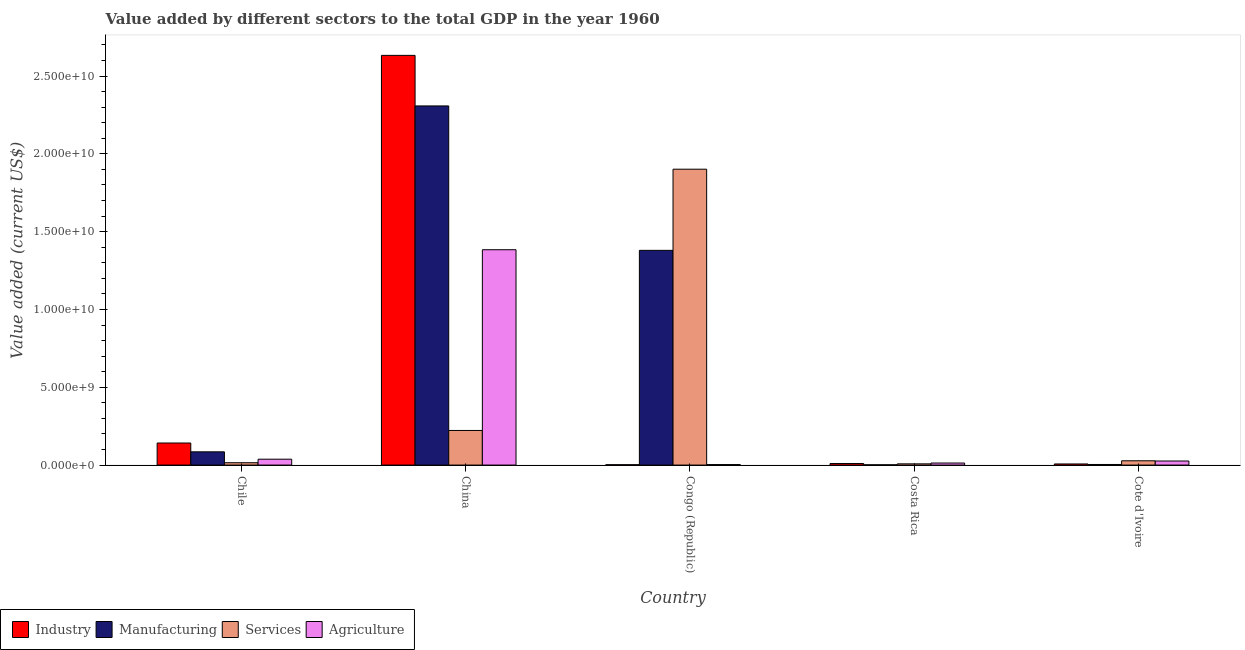Are the number of bars per tick equal to the number of legend labels?
Offer a very short reply. Yes. How many bars are there on the 3rd tick from the left?
Your answer should be compact. 4. What is the label of the 1st group of bars from the left?
Offer a very short reply. Chile. In how many cases, is the number of bars for a given country not equal to the number of legend labels?
Make the answer very short. 0. What is the value added by industrial sector in Chile?
Keep it short and to the point. 1.42e+09. Across all countries, what is the maximum value added by manufacturing sector?
Give a very brief answer. 2.31e+1. Across all countries, what is the minimum value added by agricultural sector?
Keep it short and to the point. 3.11e+07. In which country was the value added by services sector maximum?
Give a very brief answer. Congo (Republic). What is the total value added by manufacturing sector in the graph?
Your answer should be compact. 3.78e+1. What is the difference between the value added by services sector in China and that in Cote d'Ivoire?
Your response must be concise. 1.95e+09. What is the difference between the value added by industrial sector in Congo (Republic) and the value added by services sector in Chile?
Keep it short and to the point. -1.29e+08. What is the average value added by industrial sector per country?
Make the answer very short. 5.59e+09. What is the difference between the value added by industrial sector and value added by agricultural sector in China?
Offer a very short reply. 1.25e+1. In how many countries, is the value added by agricultural sector greater than 20000000000 US$?
Provide a short and direct response. 0. What is the ratio of the value added by agricultural sector in Congo (Republic) to that in Cote d'Ivoire?
Provide a succinct answer. 0.12. Is the value added by agricultural sector in Chile less than that in Costa Rica?
Offer a very short reply. No. Is the difference between the value added by manufacturing sector in Congo (Republic) and Cote d'Ivoire greater than the difference between the value added by industrial sector in Congo (Republic) and Cote d'Ivoire?
Offer a terse response. Yes. What is the difference between the highest and the second highest value added by manufacturing sector?
Make the answer very short. 9.28e+09. What is the difference between the highest and the lowest value added by manufacturing sector?
Your answer should be compact. 2.31e+1. In how many countries, is the value added by agricultural sector greater than the average value added by agricultural sector taken over all countries?
Offer a terse response. 1. Is the sum of the value added by industrial sector in Congo (Republic) and Costa Rica greater than the maximum value added by manufacturing sector across all countries?
Provide a short and direct response. No. Is it the case that in every country, the sum of the value added by manufacturing sector and value added by agricultural sector is greater than the sum of value added by industrial sector and value added by services sector?
Provide a short and direct response. Yes. What does the 3rd bar from the left in Costa Rica represents?
Offer a very short reply. Services. What does the 3rd bar from the right in Congo (Republic) represents?
Provide a short and direct response. Manufacturing. How many bars are there?
Offer a very short reply. 20. Are all the bars in the graph horizontal?
Your answer should be compact. No. Are the values on the major ticks of Y-axis written in scientific E-notation?
Your answer should be compact. Yes. Does the graph contain any zero values?
Provide a succinct answer. No. Does the graph contain grids?
Your response must be concise. No. How many legend labels are there?
Ensure brevity in your answer.  4. How are the legend labels stacked?
Provide a succinct answer. Horizontal. What is the title of the graph?
Your answer should be very brief. Value added by different sectors to the total GDP in the year 1960. What is the label or title of the Y-axis?
Make the answer very short. Value added (current US$). What is the Value added (current US$) in Industry in Chile?
Your response must be concise. 1.42e+09. What is the Value added (current US$) in Manufacturing in Chile?
Ensure brevity in your answer.  8.51e+08. What is the Value added (current US$) of Services in Chile?
Your response must be concise. 1.51e+08. What is the Value added (current US$) in Agriculture in Chile?
Give a very brief answer. 3.78e+08. What is the Value added (current US$) of Industry in China?
Offer a very short reply. 2.63e+1. What is the Value added (current US$) in Manufacturing in China?
Provide a succinct answer. 2.31e+1. What is the Value added (current US$) of Services in China?
Provide a succinct answer. 2.22e+09. What is the Value added (current US$) in Agriculture in China?
Offer a terse response. 1.38e+1. What is the Value added (current US$) of Industry in Congo (Republic)?
Give a very brief answer. 2.24e+07. What is the Value added (current US$) of Manufacturing in Congo (Republic)?
Provide a short and direct response. 1.38e+1. What is the Value added (current US$) of Services in Congo (Republic)?
Make the answer very short. 1.90e+1. What is the Value added (current US$) of Agriculture in Congo (Republic)?
Offer a very short reply. 3.11e+07. What is the Value added (current US$) in Industry in Costa Rica?
Give a very brief answer. 9.99e+07. What is the Value added (current US$) in Manufacturing in Costa Rica?
Ensure brevity in your answer.  1.59e+07. What is the Value added (current US$) of Services in Costa Rica?
Your answer should be very brief. 7.82e+07. What is the Value added (current US$) of Agriculture in Costa Rica?
Provide a short and direct response. 1.32e+08. What is the Value added (current US$) of Industry in Cote d'Ivoire?
Give a very brief answer. 7.18e+07. What is the Value added (current US$) in Manufacturing in Cote d'Ivoire?
Keep it short and to the point. 3.80e+07. What is the Value added (current US$) of Services in Cote d'Ivoire?
Your response must be concise. 2.76e+08. What is the Value added (current US$) of Agriculture in Cote d'Ivoire?
Offer a very short reply. 2.62e+08. Across all countries, what is the maximum Value added (current US$) of Industry?
Give a very brief answer. 2.63e+1. Across all countries, what is the maximum Value added (current US$) of Manufacturing?
Provide a succinct answer. 2.31e+1. Across all countries, what is the maximum Value added (current US$) of Services?
Keep it short and to the point. 1.90e+1. Across all countries, what is the maximum Value added (current US$) of Agriculture?
Offer a terse response. 1.38e+1. Across all countries, what is the minimum Value added (current US$) in Industry?
Offer a terse response. 2.24e+07. Across all countries, what is the minimum Value added (current US$) of Manufacturing?
Your answer should be compact. 1.59e+07. Across all countries, what is the minimum Value added (current US$) in Services?
Ensure brevity in your answer.  7.82e+07. Across all countries, what is the minimum Value added (current US$) in Agriculture?
Keep it short and to the point. 3.11e+07. What is the total Value added (current US$) of Industry in the graph?
Keep it short and to the point. 2.79e+1. What is the total Value added (current US$) of Manufacturing in the graph?
Provide a succinct answer. 3.78e+1. What is the total Value added (current US$) of Services in the graph?
Give a very brief answer. 2.17e+1. What is the total Value added (current US$) of Agriculture in the graph?
Offer a very short reply. 1.46e+1. What is the difference between the Value added (current US$) of Industry in Chile and that in China?
Make the answer very short. -2.49e+1. What is the difference between the Value added (current US$) of Manufacturing in Chile and that in China?
Offer a very short reply. -2.22e+1. What is the difference between the Value added (current US$) of Services in Chile and that in China?
Keep it short and to the point. -2.07e+09. What is the difference between the Value added (current US$) in Agriculture in Chile and that in China?
Offer a terse response. -1.35e+1. What is the difference between the Value added (current US$) of Industry in Chile and that in Congo (Republic)?
Provide a succinct answer. 1.40e+09. What is the difference between the Value added (current US$) in Manufacturing in Chile and that in Congo (Republic)?
Your answer should be compact. -1.29e+1. What is the difference between the Value added (current US$) of Services in Chile and that in Congo (Republic)?
Make the answer very short. -1.89e+1. What is the difference between the Value added (current US$) of Agriculture in Chile and that in Congo (Republic)?
Provide a succinct answer. 3.47e+08. What is the difference between the Value added (current US$) of Industry in Chile and that in Costa Rica?
Keep it short and to the point. 1.32e+09. What is the difference between the Value added (current US$) of Manufacturing in Chile and that in Costa Rica?
Offer a terse response. 8.35e+08. What is the difference between the Value added (current US$) of Services in Chile and that in Costa Rica?
Your answer should be very brief. 7.27e+07. What is the difference between the Value added (current US$) of Agriculture in Chile and that in Costa Rica?
Provide a succinct answer. 2.46e+08. What is the difference between the Value added (current US$) of Industry in Chile and that in Cote d'Ivoire?
Provide a succinct answer. 1.35e+09. What is the difference between the Value added (current US$) in Manufacturing in Chile and that in Cote d'Ivoire?
Offer a very short reply. 8.13e+08. What is the difference between the Value added (current US$) in Services in Chile and that in Cote d'Ivoire?
Provide a succinct answer. -1.25e+08. What is the difference between the Value added (current US$) in Agriculture in Chile and that in Cote d'Ivoire?
Provide a succinct answer. 1.16e+08. What is the difference between the Value added (current US$) in Industry in China and that in Congo (Republic)?
Provide a short and direct response. 2.63e+1. What is the difference between the Value added (current US$) in Manufacturing in China and that in Congo (Republic)?
Your response must be concise. 9.28e+09. What is the difference between the Value added (current US$) of Services in China and that in Congo (Republic)?
Offer a terse response. -1.68e+1. What is the difference between the Value added (current US$) in Agriculture in China and that in Congo (Republic)?
Offer a terse response. 1.38e+1. What is the difference between the Value added (current US$) of Industry in China and that in Costa Rica?
Provide a short and direct response. 2.62e+1. What is the difference between the Value added (current US$) in Manufacturing in China and that in Costa Rica?
Offer a very short reply. 2.31e+1. What is the difference between the Value added (current US$) in Services in China and that in Costa Rica?
Provide a short and direct response. 2.15e+09. What is the difference between the Value added (current US$) of Agriculture in China and that in Costa Rica?
Ensure brevity in your answer.  1.37e+1. What is the difference between the Value added (current US$) in Industry in China and that in Cote d'Ivoire?
Provide a short and direct response. 2.63e+1. What is the difference between the Value added (current US$) in Manufacturing in China and that in Cote d'Ivoire?
Your answer should be very brief. 2.30e+1. What is the difference between the Value added (current US$) of Services in China and that in Cote d'Ivoire?
Your answer should be compact. 1.95e+09. What is the difference between the Value added (current US$) of Agriculture in China and that in Cote d'Ivoire?
Keep it short and to the point. 1.36e+1. What is the difference between the Value added (current US$) of Industry in Congo (Republic) and that in Costa Rica?
Offer a terse response. -7.75e+07. What is the difference between the Value added (current US$) in Manufacturing in Congo (Republic) and that in Costa Rica?
Make the answer very short. 1.38e+1. What is the difference between the Value added (current US$) of Services in Congo (Republic) and that in Costa Rica?
Give a very brief answer. 1.89e+1. What is the difference between the Value added (current US$) of Agriculture in Congo (Republic) and that in Costa Rica?
Keep it short and to the point. -1.01e+08. What is the difference between the Value added (current US$) of Industry in Congo (Republic) and that in Cote d'Ivoire?
Give a very brief answer. -4.93e+07. What is the difference between the Value added (current US$) of Manufacturing in Congo (Republic) and that in Cote d'Ivoire?
Your answer should be very brief. 1.38e+1. What is the difference between the Value added (current US$) in Services in Congo (Republic) and that in Cote d'Ivoire?
Ensure brevity in your answer.  1.87e+1. What is the difference between the Value added (current US$) of Agriculture in Congo (Republic) and that in Cote d'Ivoire?
Offer a terse response. -2.31e+08. What is the difference between the Value added (current US$) in Industry in Costa Rica and that in Cote d'Ivoire?
Provide a succinct answer. 2.81e+07. What is the difference between the Value added (current US$) in Manufacturing in Costa Rica and that in Cote d'Ivoire?
Your answer should be compact. -2.22e+07. What is the difference between the Value added (current US$) of Services in Costa Rica and that in Cote d'Ivoire?
Offer a very short reply. -1.97e+08. What is the difference between the Value added (current US$) of Agriculture in Costa Rica and that in Cote d'Ivoire?
Keep it short and to the point. -1.30e+08. What is the difference between the Value added (current US$) in Industry in Chile and the Value added (current US$) in Manufacturing in China?
Offer a terse response. -2.17e+1. What is the difference between the Value added (current US$) in Industry in Chile and the Value added (current US$) in Services in China?
Your answer should be compact. -8.07e+08. What is the difference between the Value added (current US$) in Industry in Chile and the Value added (current US$) in Agriculture in China?
Keep it short and to the point. -1.24e+1. What is the difference between the Value added (current US$) in Manufacturing in Chile and the Value added (current US$) in Services in China?
Offer a terse response. -1.37e+09. What is the difference between the Value added (current US$) of Manufacturing in Chile and the Value added (current US$) of Agriculture in China?
Your answer should be compact. -1.30e+1. What is the difference between the Value added (current US$) of Services in Chile and the Value added (current US$) of Agriculture in China?
Keep it short and to the point. -1.37e+1. What is the difference between the Value added (current US$) in Industry in Chile and the Value added (current US$) in Manufacturing in Congo (Republic)?
Offer a very short reply. -1.24e+1. What is the difference between the Value added (current US$) of Industry in Chile and the Value added (current US$) of Services in Congo (Republic)?
Ensure brevity in your answer.  -1.76e+1. What is the difference between the Value added (current US$) in Industry in Chile and the Value added (current US$) in Agriculture in Congo (Republic)?
Offer a terse response. 1.39e+09. What is the difference between the Value added (current US$) in Manufacturing in Chile and the Value added (current US$) in Services in Congo (Republic)?
Provide a succinct answer. -1.82e+1. What is the difference between the Value added (current US$) in Manufacturing in Chile and the Value added (current US$) in Agriculture in Congo (Republic)?
Offer a very short reply. 8.20e+08. What is the difference between the Value added (current US$) of Services in Chile and the Value added (current US$) of Agriculture in Congo (Republic)?
Your answer should be compact. 1.20e+08. What is the difference between the Value added (current US$) in Industry in Chile and the Value added (current US$) in Manufacturing in Costa Rica?
Offer a terse response. 1.40e+09. What is the difference between the Value added (current US$) of Industry in Chile and the Value added (current US$) of Services in Costa Rica?
Your response must be concise. 1.34e+09. What is the difference between the Value added (current US$) in Industry in Chile and the Value added (current US$) in Agriculture in Costa Rica?
Provide a succinct answer. 1.29e+09. What is the difference between the Value added (current US$) of Manufacturing in Chile and the Value added (current US$) of Services in Costa Rica?
Your response must be concise. 7.72e+08. What is the difference between the Value added (current US$) of Manufacturing in Chile and the Value added (current US$) of Agriculture in Costa Rica?
Provide a succinct answer. 7.19e+08. What is the difference between the Value added (current US$) in Services in Chile and the Value added (current US$) in Agriculture in Costa Rica?
Ensure brevity in your answer.  1.88e+07. What is the difference between the Value added (current US$) of Industry in Chile and the Value added (current US$) of Manufacturing in Cote d'Ivoire?
Offer a very short reply. 1.38e+09. What is the difference between the Value added (current US$) in Industry in Chile and the Value added (current US$) in Services in Cote d'Ivoire?
Your response must be concise. 1.14e+09. What is the difference between the Value added (current US$) of Industry in Chile and the Value added (current US$) of Agriculture in Cote d'Ivoire?
Keep it short and to the point. 1.16e+09. What is the difference between the Value added (current US$) in Manufacturing in Chile and the Value added (current US$) in Services in Cote d'Ivoire?
Offer a very short reply. 5.75e+08. What is the difference between the Value added (current US$) in Manufacturing in Chile and the Value added (current US$) in Agriculture in Cote d'Ivoire?
Ensure brevity in your answer.  5.89e+08. What is the difference between the Value added (current US$) of Services in Chile and the Value added (current US$) of Agriculture in Cote d'Ivoire?
Make the answer very short. -1.11e+08. What is the difference between the Value added (current US$) in Industry in China and the Value added (current US$) in Manufacturing in Congo (Republic)?
Your answer should be very brief. 1.25e+1. What is the difference between the Value added (current US$) in Industry in China and the Value added (current US$) in Services in Congo (Republic)?
Make the answer very short. 7.32e+09. What is the difference between the Value added (current US$) in Industry in China and the Value added (current US$) in Agriculture in Congo (Republic)?
Your answer should be compact. 2.63e+1. What is the difference between the Value added (current US$) of Manufacturing in China and the Value added (current US$) of Services in Congo (Republic)?
Give a very brief answer. 4.07e+09. What is the difference between the Value added (current US$) in Manufacturing in China and the Value added (current US$) in Agriculture in Congo (Republic)?
Provide a succinct answer. 2.30e+1. What is the difference between the Value added (current US$) of Services in China and the Value added (current US$) of Agriculture in Congo (Republic)?
Give a very brief answer. 2.19e+09. What is the difference between the Value added (current US$) in Industry in China and the Value added (current US$) in Manufacturing in Costa Rica?
Provide a succinct answer. 2.63e+1. What is the difference between the Value added (current US$) of Industry in China and the Value added (current US$) of Services in Costa Rica?
Offer a terse response. 2.63e+1. What is the difference between the Value added (current US$) of Industry in China and the Value added (current US$) of Agriculture in Costa Rica?
Ensure brevity in your answer.  2.62e+1. What is the difference between the Value added (current US$) in Manufacturing in China and the Value added (current US$) in Services in Costa Rica?
Make the answer very short. 2.30e+1. What is the difference between the Value added (current US$) of Manufacturing in China and the Value added (current US$) of Agriculture in Costa Rica?
Provide a short and direct response. 2.29e+1. What is the difference between the Value added (current US$) of Services in China and the Value added (current US$) of Agriculture in Costa Rica?
Offer a very short reply. 2.09e+09. What is the difference between the Value added (current US$) in Industry in China and the Value added (current US$) in Manufacturing in Cote d'Ivoire?
Provide a short and direct response. 2.63e+1. What is the difference between the Value added (current US$) in Industry in China and the Value added (current US$) in Services in Cote d'Ivoire?
Make the answer very short. 2.61e+1. What is the difference between the Value added (current US$) in Industry in China and the Value added (current US$) in Agriculture in Cote d'Ivoire?
Offer a terse response. 2.61e+1. What is the difference between the Value added (current US$) of Manufacturing in China and the Value added (current US$) of Services in Cote d'Ivoire?
Offer a very short reply. 2.28e+1. What is the difference between the Value added (current US$) of Manufacturing in China and the Value added (current US$) of Agriculture in Cote d'Ivoire?
Offer a very short reply. 2.28e+1. What is the difference between the Value added (current US$) of Services in China and the Value added (current US$) of Agriculture in Cote d'Ivoire?
Provide a short and direct response. 1.96e+09. What is the difference between the Value added (current US$) in Industry in Congo (Republic) and the Value added (current US$) in Manufacturing in Costa Rica?
Provide a short and direct response. 6.56e+06. What is the difference between the Value added (current US$) in Industry in Congo (Republic) and the Value added (current US$) in Services in Costa Rica?
Your answer should be compact. -5.58e+07. What is the difference between the Value added (current US$) of Industry in Congo (Republic) and the Value added (current US$) of Agriculture in Costa Rica?
Your answer should be very brief. -1.10e+08. What is the difference between the Value added (current US$) of Manufacturing in Congo (Republic) and the Value added (current US$) of Services in Costa Rica?
Provide a short and direct response. 1.37e+1. What is the difference between the Value added (current US$) of Manufacturing in Congo (Republic) and the Value added (current US$) of Agriculture in Costa Rica?
Your response must be concise. 1.37e+1. What is the difference between the Value added (current US$) in Services in Congo (Republic) and the Value added (current US$) in Agriculture in Costa Rica?
Provide a short and direct response. 1.89e+1. What is the difference between the Value added (current US$) of Industry in Congo (Republic) and the Value added (current US$) of Manufacturing in Cote d'Ivoire?
Your response must be concise. -1.56e+07. What is the difference between the Value added (current US$) of Industry in Congo (Republic) and the Value added (current US$) of Services in Cote d'Ivoire?
Your answer should be very brief. -2.53e+08. What is the difference between the Value added (current US$) in Industry in Congo (Republic) and the Value added (current US$) in Agriculture in Cote d'Ivoire?
Offer a very short reply. -2.39e+08. What is the difference between the Value added (current US$) of Manufacturing in Congo (Republic) and the Value added (current US$) of Services in Cote d'Ivoire?
Provide a succinct answer. 1.35e+1. What is the difference between the Value added (current US$) in Manufacturing in Congo (Republic) and the Value added (current US$) in Agriculture in Cote d'Ivoire?
Offer a very short reply. 1.35e+1. What is the difference between the Value added (current US$) of Services in Congo (Republic) and the Value added (current US$) of Agriculture in Cote d'Ivoire?
Ensure brevity in your answer.  1.88e+1. What is the difference between the Value added (current US$) of Industry in Costa Rica and the Value added (current US$) of Manufacturing in Cote d'Ivoire?
Provide a succinct answer. 6.18e+07. What is the difference between the Value added (current US$) of Industry in Costa Rica and the Value added (current US$) of Services in Cote d'Ivoire?
Your answer should be very brief. -1.76e+08. What is the difference between the Value added (current US$) of Industry in Costa Rica and the Value added (current US$) of Agriculture in Cote d'Ivoire?
Provide a short and direct response. -1.62e+08. What is the difference between the Value added (current US$) of Manufacturing in Costa Rica and the Value added (current US$) of Services in Cote d'Ivoire?
Offer a very short reply. -2.60e+08. What is the difference between the Value added (current US$) of Manufacturing in Costa Rica and the Value added (current US$) of Agriculture in Cote d'Ivoire?
Ensure brevity in your answer.  -2.46e+08. What is the difference between the Value added (current US$) in Services in Costa Rica and the Value added (current US$) in Agriculture in Cote d'Ivoire?
Your response must be concise. -1.83e+08. What is the average Value added (current US$) in Industry per country?
Your answer should be compact. 5.59e+09. What is the average Value added (current US$) of Manufacturing per country?
Provide a succinct answer. 7.56e+09. What is the average Value added (current US$) of Services per country?
Provide a succinct answer. 4.35e+09. What is the average Value added (current US$) in Agriculture per country?
Make the answer very short. 2.93e+09. What is the difference between the Value added (current US$) in Industry and Value added (current US$) in Manufacturing in Chile?
Your answer should be compact. 5.67e+08. What is the difference between the Value added (current US$) of Industry and Value added (current US$) of Services in Chile?
Your response must be concise. 1.27e+09. What is the difference between the Value added (current US$) of Industry and Value added (current US$) of Agriculture in Chile?
Provide a succinct answer. 1.04e+09. What is the difference between the Value added (current US$) of Manufacturing and Value added (current US$) of Services in Chile?
Offer a very short reply. 7.00e+08. What is the difference between the Value added (current US$) of Manufacturing and Value added (current US$) of Agriculture in Chile?
Provide a succinct answer. 4.73e+08. What is the difference between the Value added (current US$) in Services and Value added (current US$) in Agriculture in Chile?
Provide a succinct answer. -2.27e+08. What is the difference between the Value added (current US$) of Industry and Value added (current US$) of Manufacturing in China?
Offer a very short reply. 3.25e+09. What is the difference between the Value added (current US$) of Industry and Value added (current US$) of Services in China?
Offer a very short reply. 2.41e+1. What is the difference between the Value added (current US$) of Industry and Value added (current US$) of Agriculture in China?
Keep it short and to the point. 1.25e+1. What is the difference between the Value added (current US$) in Manufacturing and Value added (current US$) in Services in China?
Your response must be concise. 2.09e+1. What is the difference between the Value added (current US$) of Manufacturing and Value added (current US$) of Agriculture in China?
Offer a very short reply. 9.24e+09. What is the difference between the Value added (current US$) of Services and Value added (current US$) of Agriculture in China?
Offer a terse response. -1.16e+1. What is the difference between the Value added (current US$) in Industry and Value added (current US$) in Manufacturing in Congo (Republic)?
Provide a succinct answer. -1.38e+1. What is the difference between the Value added (current US$) in Industry and Value added (current US$) in Services in Congo (Republic)?
Your answer should be very brief. -1.90e+1. What is the difference between the Value added (current US$) of Industry and Value added (current US$) of Agriculture in Congo (Republic)?
Your answer should be very brief. -8.66e+06. What is the difference between the Value added (current US$) in Manufacturing and Value added (current US$) in Services in Congo (Republic)?
Keep it short and to the point. -5.22e+09. What is the difference between the Value added (current US$) in Manufacturing and Value added (current US$) in Agriculture in Congo (Republic)?
Offer a terse response. 1.38e+1. What is the difference between the Value added (current US$) in Services and Value added (current US$) in Agriculture in Congo (Republic)?
Your answer should be very brief. 1.90e+1. What is the difference between the Value added (current US$) in Industry and Value added (current US$) in Manufacturing in Costa Rica?
Ensure brevity in your answer.  8.40e+07. What is the difference between the Value added (current US$) in Industry and Value added (current US$) in Services in Costa Rica?
Offer a very short reply. 2.17e+07. What is the difference between the Value added (current US$) of Industry and Value added (current US$) of Agriculture in Costa Rica?
Ensure brevity in your answer.  -3.22e+07. What is the difference between the Value added (current US$) in Manufacturing and Value added (current US$) in Services in Costa Rica?
Your response must be concise. -6.23e+07. What is the difference between the Value added (current US$) in Manufacturing and Value added (current US$) in Agriculture in Costa Rica?
Your answer should be very brief. -1.16e+08. What is the difference between the Value added (current US$) in Services and Value added (current US$) in Agriculture in Costa Rica?
Your answer should be very brief. -5.39e+07. What is the difference between the Value added (current US$) in Industry and Value added (current US$) in Manufacturing in Cote d'Ivoire?
Offer a terse response. 3.37e+07. What is the difference between the Value added (current US$) of Industry and Value added (current US$) of Services in Cote d'Ivoire?
Keep it short and to the point. -2.04e+08. What is the difference between the Value added (current US$) in Industry and Value added (current US$) in Agriculture in Cote d'Ivoire?
Make the answer very short. -1.90e+08. What is the difference between the Value added (current US$) of Manufacturing and Value added (current US$) of Services in Cote d'Ivoire?
Provide a short and direct response. -2.37e+08. What is the difference between the Value added (current US$) of Manufacturing and Value added (current US$) of Agriculture in Cote d'Ivoire?
Provide a succinct answer. -2.24e+08. What is the difference between the Value added (current US$) of Services and Value added (current US$) of Agriculture in Cote d'Ivoire?
Your answer should be very brief. 1.38e+07. What is the ratio of the Value added (current US$) in Industry in Chile to that in China?
Your response must be concise. 0.05. What is the ratio of the Value added (current US$) of Manufacturing in Chile to that in China?
Keep it short and to the point. 0.04. What is the ratio of the Value added (current US$) in Services in Chile to that in China?
Keep it short and to the point. 0.07. What is the ratio of the Value added (current US$) in Agriculture in Chile to that in China?
Keep it short and to the point. 0.03. What is the ratio of the Value added (current US$) of Industry in Chile to that in Congo (Republic)?
Offer a very short reply. 63.21. What is the ratio of the Value added (current US$) in Manufacturing in Chile to that in Congo (Republic)?
Ensure brevity in your answer.  0.06. What is the ratio of the Value added (current US$) of Services in Chile to that in Congo (Republic)?
Your response must be concise. 0.01. What is the ratio of the Value added (current US$) in Agriculture in Chile to that in Congo (Republic)?
Your response must be concise. 12.16. What is the ratio of the Value added (current US$) in Industry in Chile to that in Costa Rica?
Your answer should be very brief. 14.19. What is the ratio of the Value added (current US$) of Manufacturing in Chile to that in Costa Rica?
Give a very brief answer. 53.62. What is the ratio of the Value added (current US$) of Services in Chile to that in Costa Rica?
Your answer should be compact. 1.93. What is the ratio of the Value added (current US$) of Agriculture in Chile to that in Costa Rica?
Your answer should be compact. 2.86. What is the ratio of the Value added (current US$) in Industry in Chile to that in Cote d'Ivoire?
Provide a short and direct response. 19.76. What is the ratio of the Value added (current US$) in Manufacturing in Chile to that in Cote d'Ivoire?
Give a very brief answer. 22.36. What is the ratio of the Value added (current US$) of Services in Chile to that in Cote d'Ivoire?
Offer a very short reply. 0.55. What is the ratio of the Value added (current US$) of Agriculture in Chile to that in Cote d'Ivoire?
Offer a terse response. 1.44. What is the ratio of the Value added (current US$) of Industry in China to that in Congo (Republic)?
Offer a very short reply. 1173.83. What is the ratio of the Value added (current US$) of Manufacturing in China to that in Congo (Republic)?
Offer a terse response. 1.67. What is the ratio of the Value added (current US$) of Services in China to that in Congo (Republic)?
Keep it short and to the point. 0.12. What is the ratio of the Value added (current US$) in Agriculture in China to that in Congo (Republic)?
Ensure brevity in your answer.  445.15. What is the ratio of the Value added (current US$) in Industry in China to that in Costa Rica?
Offer a very short reply. 263.6. What is the ratio of the Value added (current US$) in Manufacturing in China to that in Costa Rica?
Keep it short and to the point. 1454.66. What is the ratio of the Value added (current US$) in Services in China to that in Costa Rica?
Ensure brevity in your answer.  28.44. What is the ratio of the Value added (current US$) in Agriculture in China to that in Costa Rica?
Offer a terse response. 104.74. What is the ratio of the Value added (current US$) of Industry in China to that in Cote d'Ivoire?
Ensure brevity in your answer.  366.9. What is the ratio of the Value added (current US$) in Manufacturing in China to that in Cote d'Ivoire?
Keep it short and to the point. 606.59. What is the ratio of the Value added (current US$) of Services in China to that in Cote d'Ivoire?
Keep it short and to the point. 8.07. What is the ratio of the Value added (current US$) in Agriculture in China to that in Cote d'Ivoire?
Give a very brief answer. 52.89. What is the ratio of the Value added (current US$) of Industry in Congo (Republic) to that in Costa Rica?
Keep it short and to the point. 0.22. What is the ratio of the Value added (current US$) of Manufacturing in Congo (Republic) to that in Costa Rica?
Ensure brevity in your answer.  869.7. What is the ratio of the Value added (current US$) of Services in Congo (Republic) to that in Costa Rica?
Offer a terse response. 243.12. What is the ratio of the Value added (current US$) in Agriculture in Congo (Republic) to that in Costa Rica?
Make the answer very short. 0.24. What is the ratio of the Value added (current US$) of Industry in Congo (Republic) to that in Cote d'Ivoire?
Ensure brevity in your answer.  0.31. What is the ratio of the Value added (current US$) in Manufacturing in Congo (Republic) to that in Cote d'Ivoire?
Offer a terse response. 362.66. What is the ratio of the Value added (current US$) of Services in Congo (Republic) to that in Cote d'Ivoire?
Keep it short and to the point. 69.02. What is the ratio of the Value added (current US$) in Agriculture in Congo (Republic) to that in Cote d'Ivoire?
Ensure brevity in your answer.  0.12. What is the ratio of the Value added (current US$) in Industry in Costa Rica to that in Cote d'Ivoire?
Make the answer very short. 1.39. What is the ratio of the Value added (current US$) of Manufacturing in Costa Rica to that in Cote d'Ivoire?
Keep it short and to the point. 0.42. What is the ratio of the Value added (current US$) of Services in Costa Rica to that in Cote d'Ivoire?
Ensure brevity in your answer.  0.28. What is the ratio of the Value added (current US$) in Agriculture in Costa Rica to that in Cote d'Ivoire?
Your answer should be compact. 0.5. What is the difference between the highest and the second highest Value added (current US$) of Industry?
Give a very brief answer. 2.49e+1. What is the difference between the highest and the second highest Value added (current US$) of Manufacturing?
Offer a terse response. 9.28e+09. What is the difference between the highest and the second highest Value added (current US$) of Services?
Provide a short and direct response. 1.68e+1. What is the difference between the highest and the second highest Value added (current US$) of Agriculture?
Offer a very short reply. 1.35e+1. What is the difference between the highest and the lowest Value added (current US$) of Industry?
Ensure brevity in your answer.  2.63e+1. What is the difference between the highest and the lowest Value added (current US$) in Manufacturing?
Your answer should be very brief. 2.31e+1. What is the difference between the highest and the lowest Value added (current US$) in Services?
Your answer should be compact. 1.89e+1. What is the difference between the highest and the lowest Value added (current US$) in Agriculture?
Provide a succinct answer. 1.38e+1. 